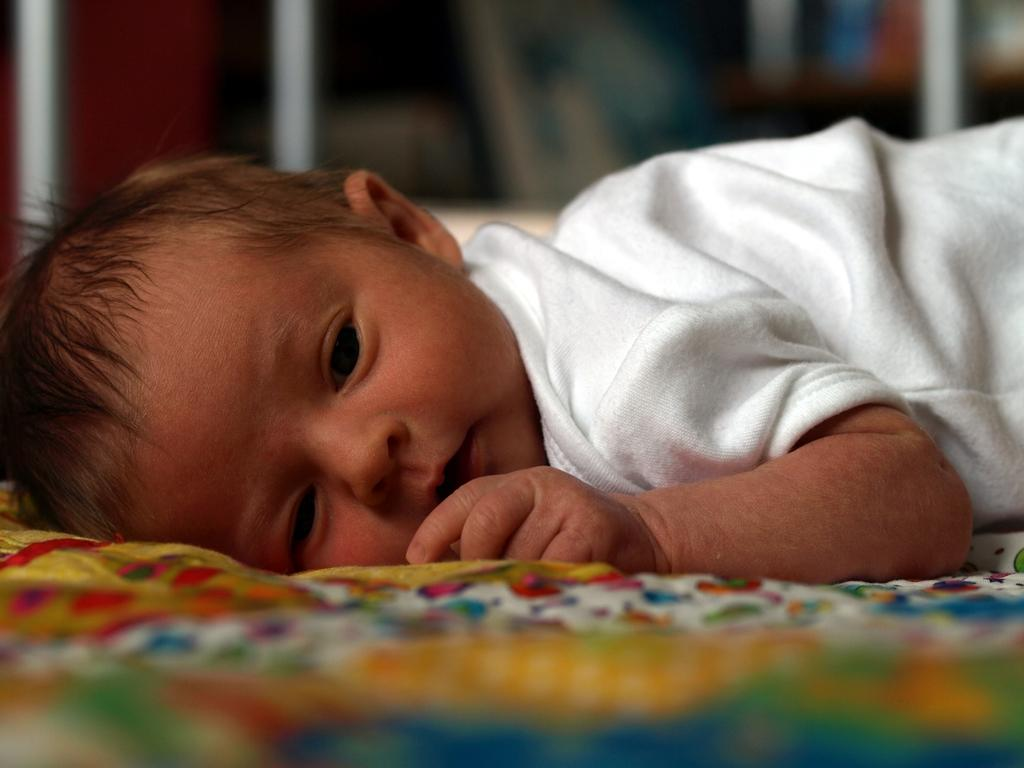What is the main subject of the image? There is a baby in the image. What is the baby wearing? The baby is wearing a white dress. Where is the baby located in the image? The baby is lying on a bed. What else can be seen in the background of the image? There are other objects in the background of the image. What type of flowers can be seen on the sofa in the image? There is no sofa or flowers present in the image. Is the zebra in the image playing with the baby? There is no zebra present in the image. 